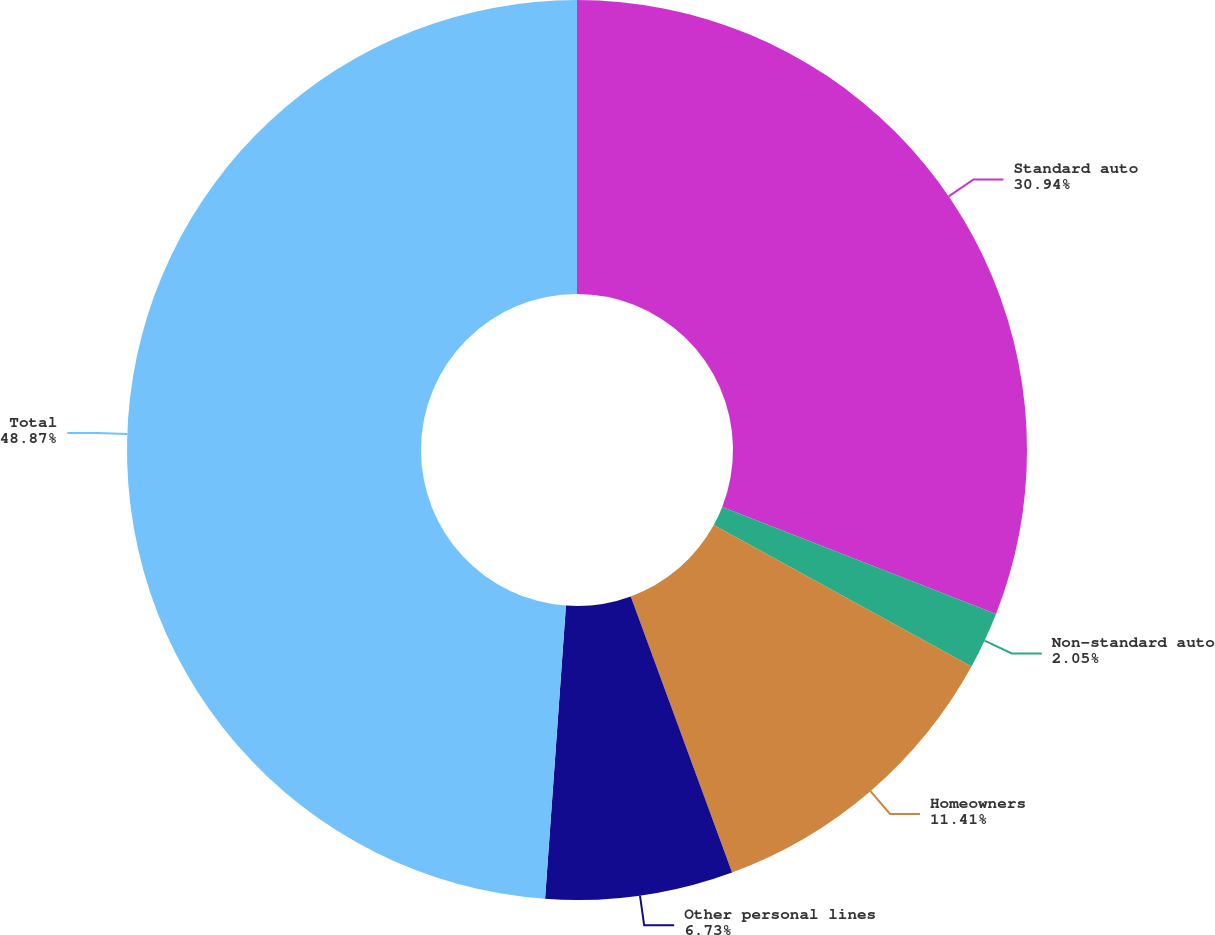Convert chart to OTSL. <chart><loc_0><loc_0><loc_500><loc_500><pie_chart><fcel>Standard auto<fcel>Non-standard auto<fcel>Homeowners<fcel>Other personal lines<fcel>Total<nl><fcel>30.94%<fcel>2.05%<fcel>11.41%<fcel>6.73%<fcel>48.87%<nl></chart> 